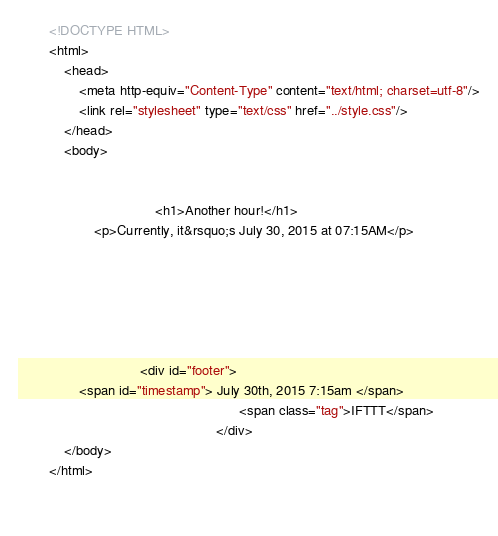Convert code to text. <code><loc_0><loc_0><loc_500><loc_500><_HTML_>        <!DOCTYPE HTML>
        <html>
            <head>
                <meta http-equiv="Content-Type" content="text/html; charset=utf-8"/>
                <link rel="stylesheet" type="text/css" href="../style.css"/>
            </head>
            <body>
                
                
                                    <h1>Another hour!</h1>
                    <p>Currently, it&rsquo;s July 30, 2015 at 07:15AM</p>
                
                
                
                
                
                
                                <div id="footer">
                <span id="timestamp"> July 30th, 2015 7:15am </span>
                                                          <span class="tag">IFTTT</span>
                                                    </div>
            </body>
        </html>

        </code> 